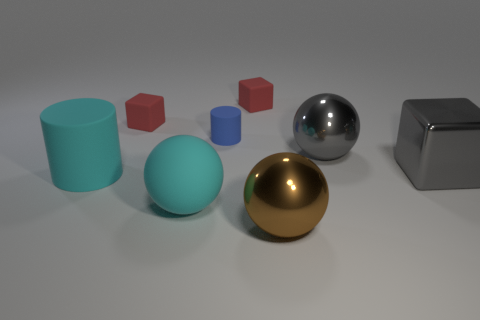Subtract all purple cylinders. How many red cubes are left? 2 Subtract all tiny blocks. How many blocks are left? 1 Add 2 large brown objects. How many objects exist? 10 Subtract all spheres. How many objects are left? 5 Add 5 large gray balls. How many large gray balls exist? 6 Subtract 0 red cylinders. How many objects are left? 8 Subtract all big gray metal spheres. Subtract all small blue rubber cylinders. How many objects are left? 6 Add 1 gray metal balls. How many gray metal balls are left? 2 